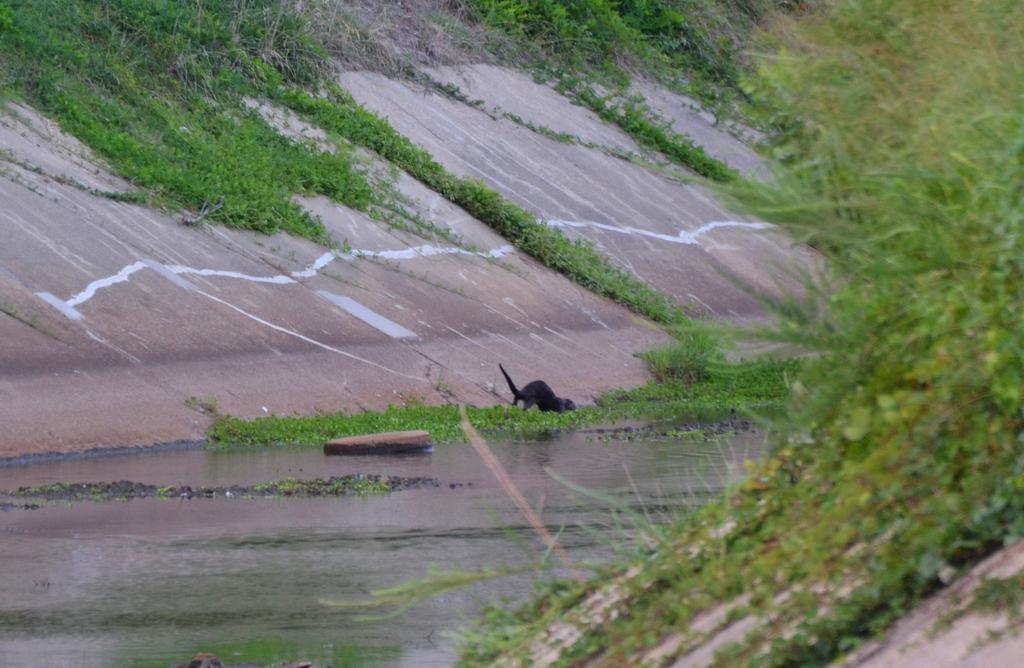In one or two sentences, can you explain what this image depicts? This image is taken outdoors. In the middle of the image there is a lake with water and a few water plants. In the background there is a wall and there is a ground with grass on it. There are a few plants and creepers. There is an animal. On the right side of the image there is a ground with grass on it and there are many plants. 